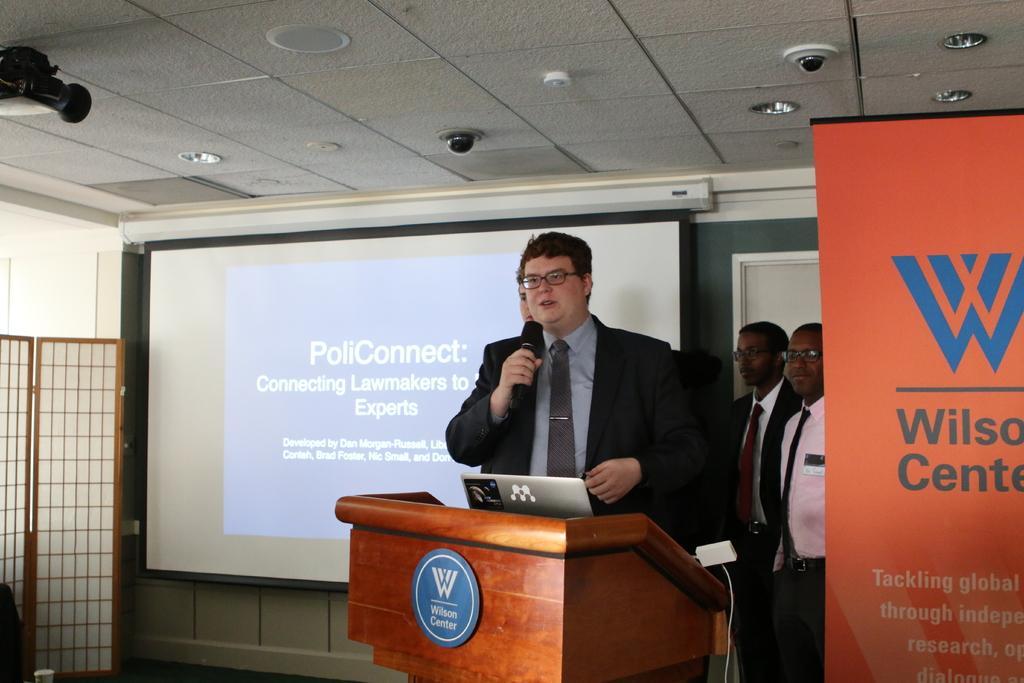Please provide a concise description of this image. In this picture I can see people standing. I can see a person holding microphone. I can see wooden podium. I can see light arrangements on the roof. I can see the projector and the screen. I can see the banner on the right side. 